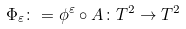Convert formula to latex. <formula><loc_0><loc_0><loc_500><loc_500>\Phi _ { \varepsilon } \colon = \phi ^ { \varepsilon } \circ A \colon T ^ { 2 } \to T ^ { 2 }</formula> 